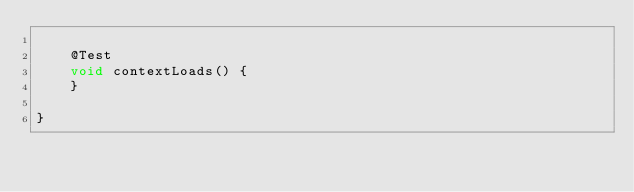<code> <loc_0><loc_0><loc_500><loc_500><_Java_>
    @Test
    void contextLoads() {
    }

}
</code> 